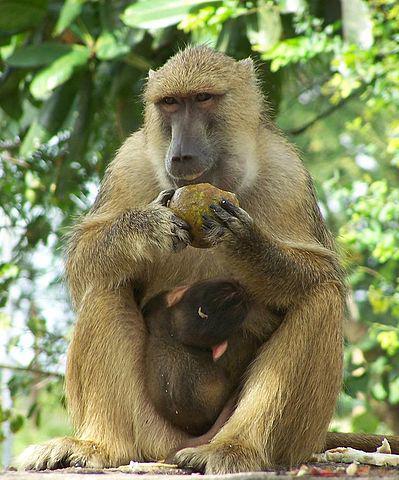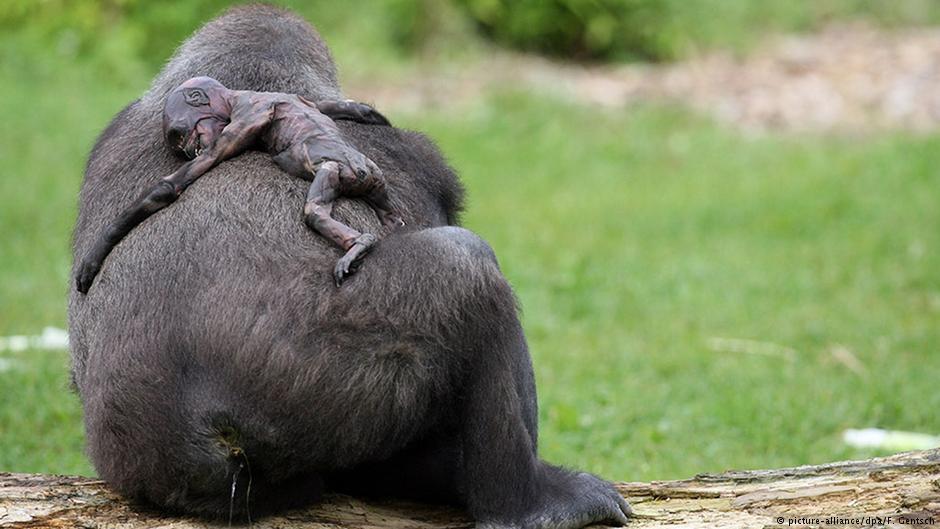The first image is the image on the left, the second image is the image on the right. For the images displayed, is the sentence "The feet of the adult monkey can be seen in the image on the left." factually correct? Answer yes or no. Yes. 